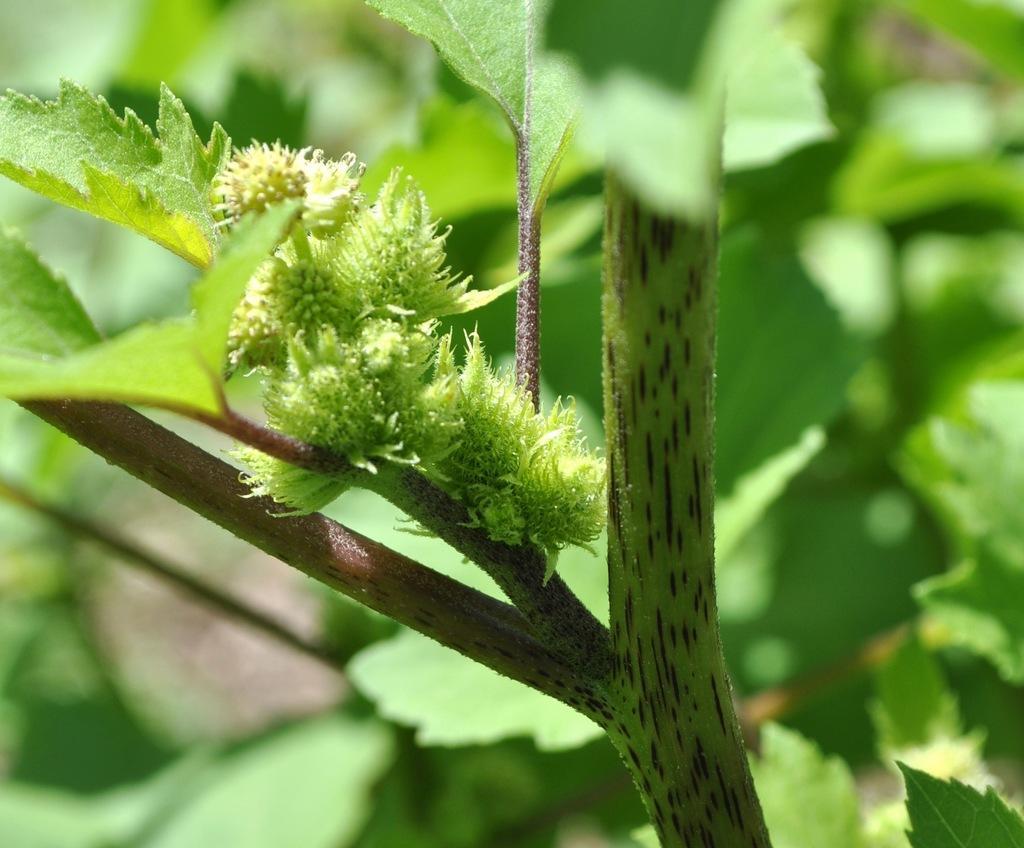In one or two sentences, can you explain what this image depicts? In this image we can see plants and tree, and the background is blurred. 